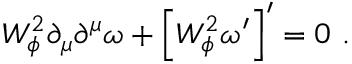<formula> <loc_0><loc_0><loc_500><loc_500>W _ { \phi } ^ { 2 } \partial _ { \mu } \partial ^ { \mu } \omega + \left [ W _ { \phi } ^ { 2 } \omega ^ { \prime } \right ] ^ { \prime } = 0 .</formula> 